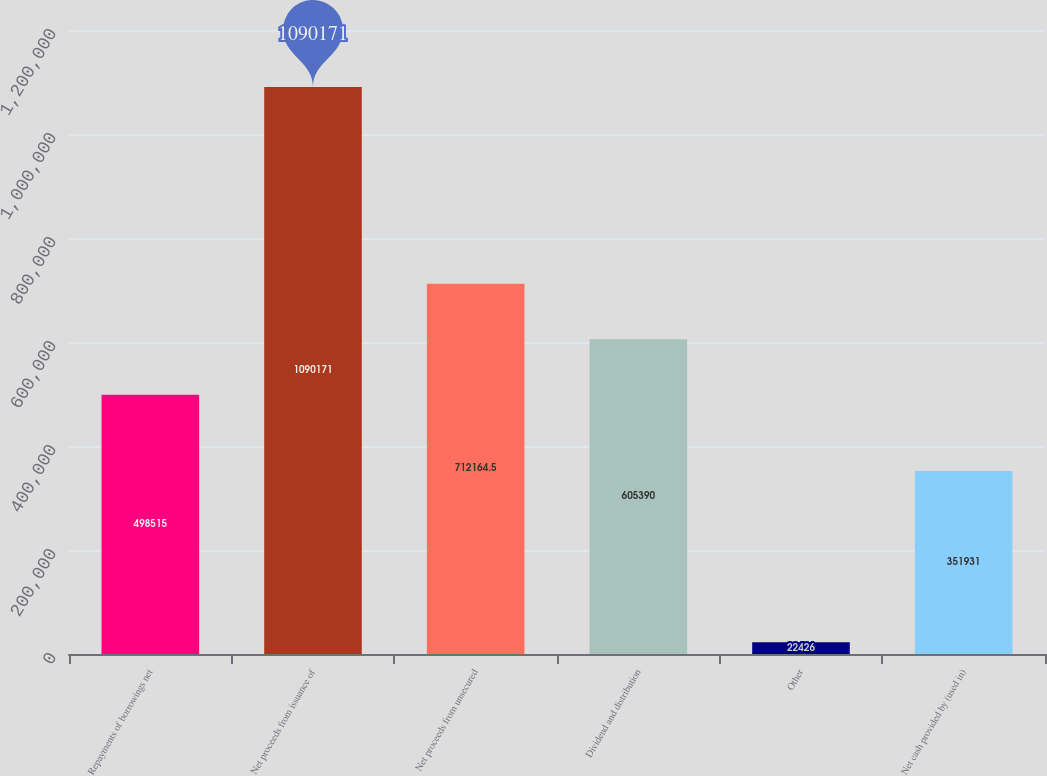Convert chart. <chart><loc_0><loc_0><loc_500><loc_500><bar_chart><fcel>Repayments of borrowings net<fcel>Net proceeds from issuance of<fcel>Net proceeds from unsecured<fcel>Dividend and distribution<fcel>Other<fcel>Net cash provided by (used in)<nl><fcel>498515<fcel>1.09017e+06<fcel>712164<fcel>605390<fcel>22426<fcel>351931<nl></chart> 